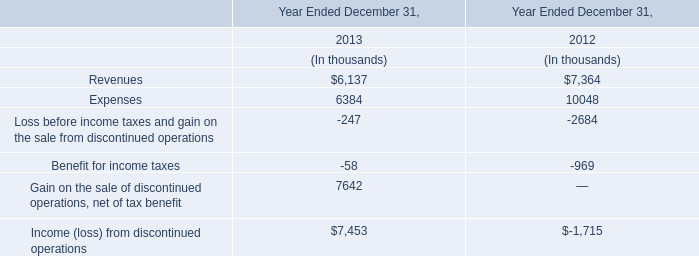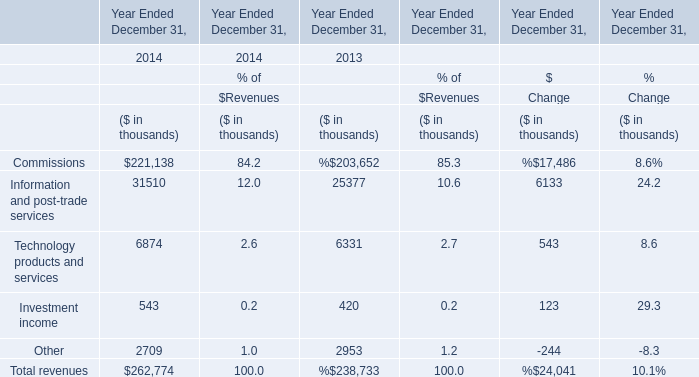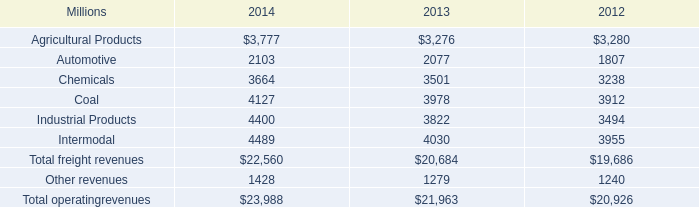What is the sum of Revenues for Year Ended December 31, in 2013 and Commissions for Year Ended December 31, in 2014? (in thousand) 
Computations: (6137 + 221138)
Answer: 227275.0. 